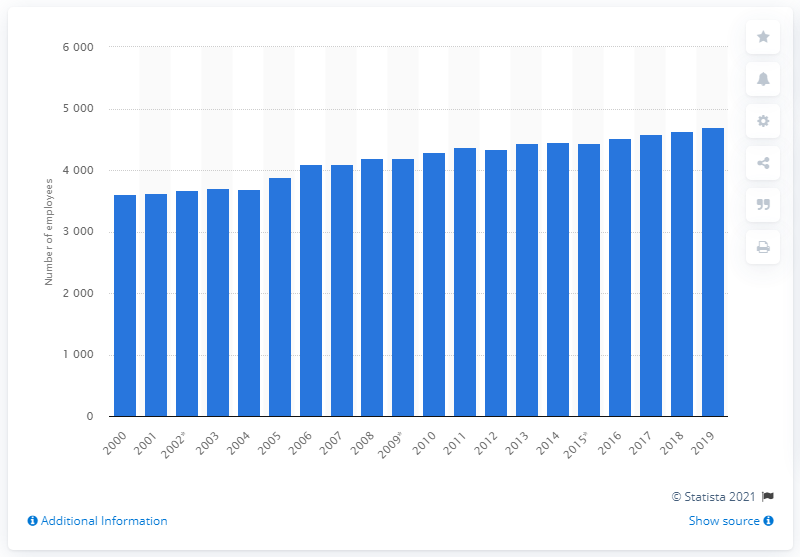Identify some key points in this picture. In 2019, there were approximately 4,703 dentists employed in Norway. 